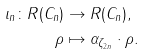<formula> <loc_0><loc_0><loc_500><loc_500>\iota _ { n } \colon R ( C _ { n } ) & \to R ( C _ { n } ) , \\ \rho & \mapsto \alpha _ { \zeta _ { 2 n } } \cdot \rho .</formula> 